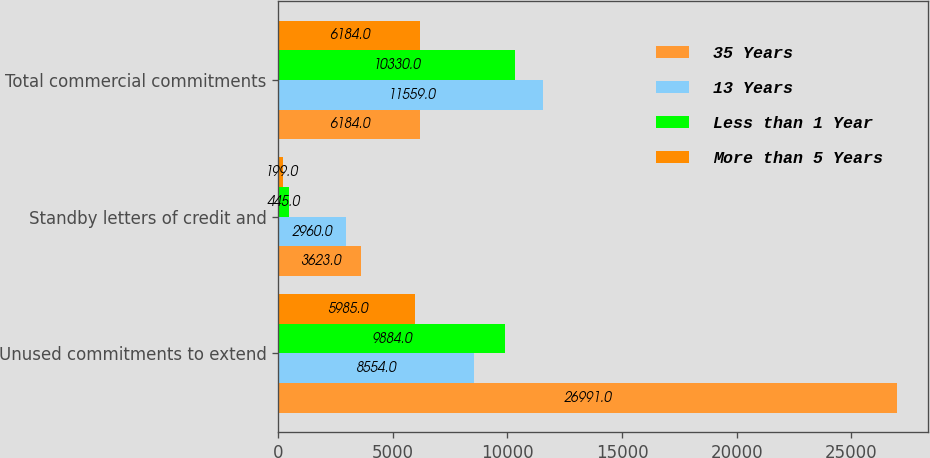Convert chart. <chart><loc_0><loc_0><loc_500><loc_500><stacked_bar_chart><ecel><fcel>Unused commitments to extend<fcel>Standby letters of credit and<fcel>Total commercial commitments<nl><fcel>35 Years<fcel>26991<fcel>3623<fcel>6184<nl><fcel>13 Years<fcel>8554<fcel>2960<fcel>11559<nl><fcel>Less than 1 Year<fcel>9884<fcel>445<fcel>10330<nl><fcel>More than 5 Years<fcel>5985<fcel>199<fcel>6184<nl></chart> 